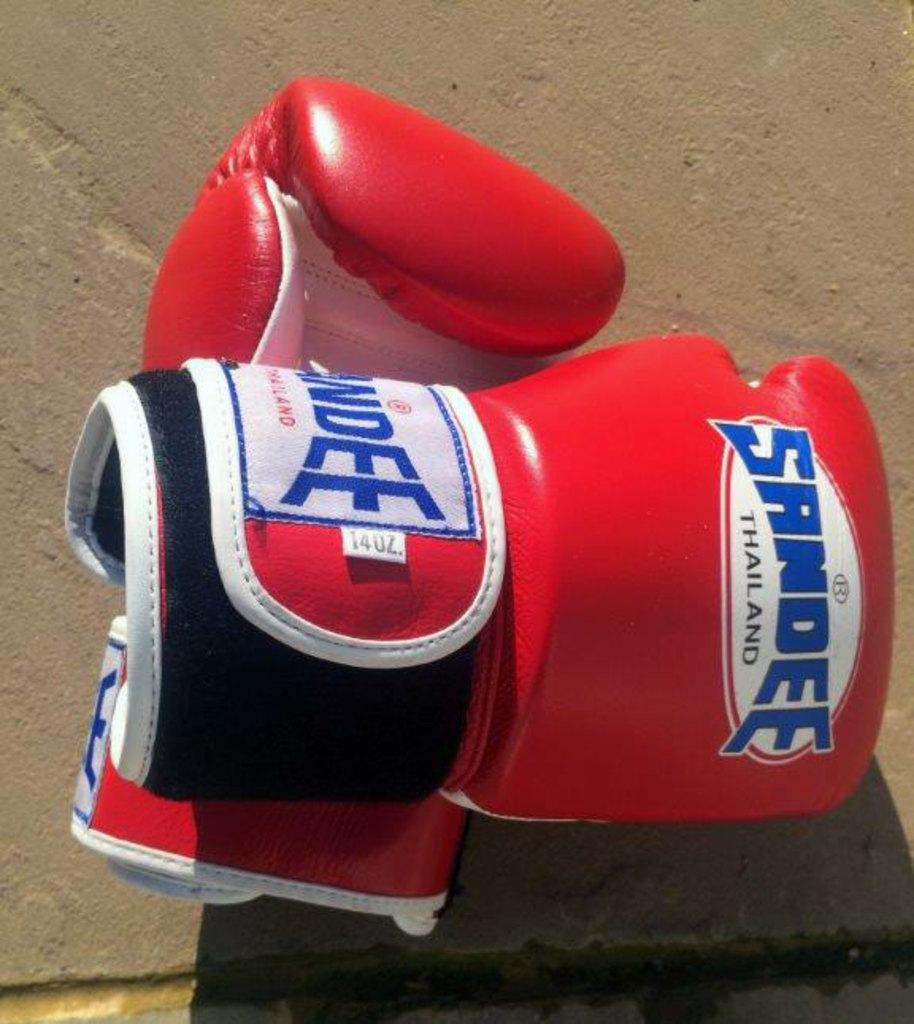<image>
Provide a brief description of the given image. The boxing gloves are from the brand Sandee Thailand. 